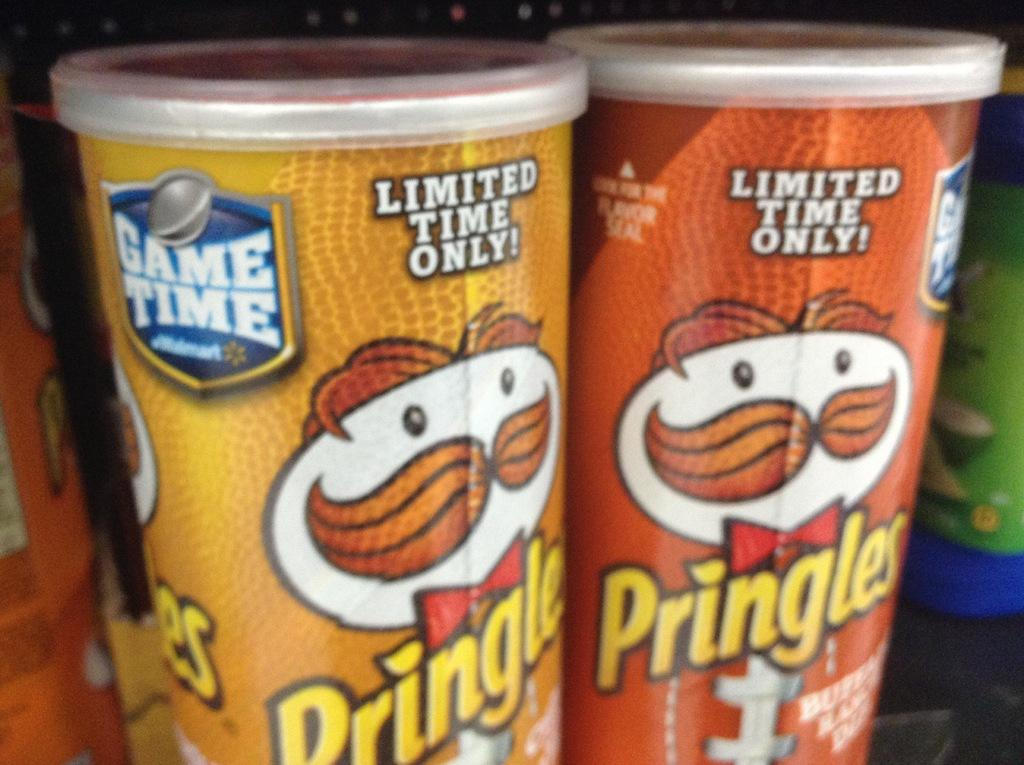<image>
Present a compact description of the photo's key features. A few pringles containers show Limited Time Only on the top by the lid 